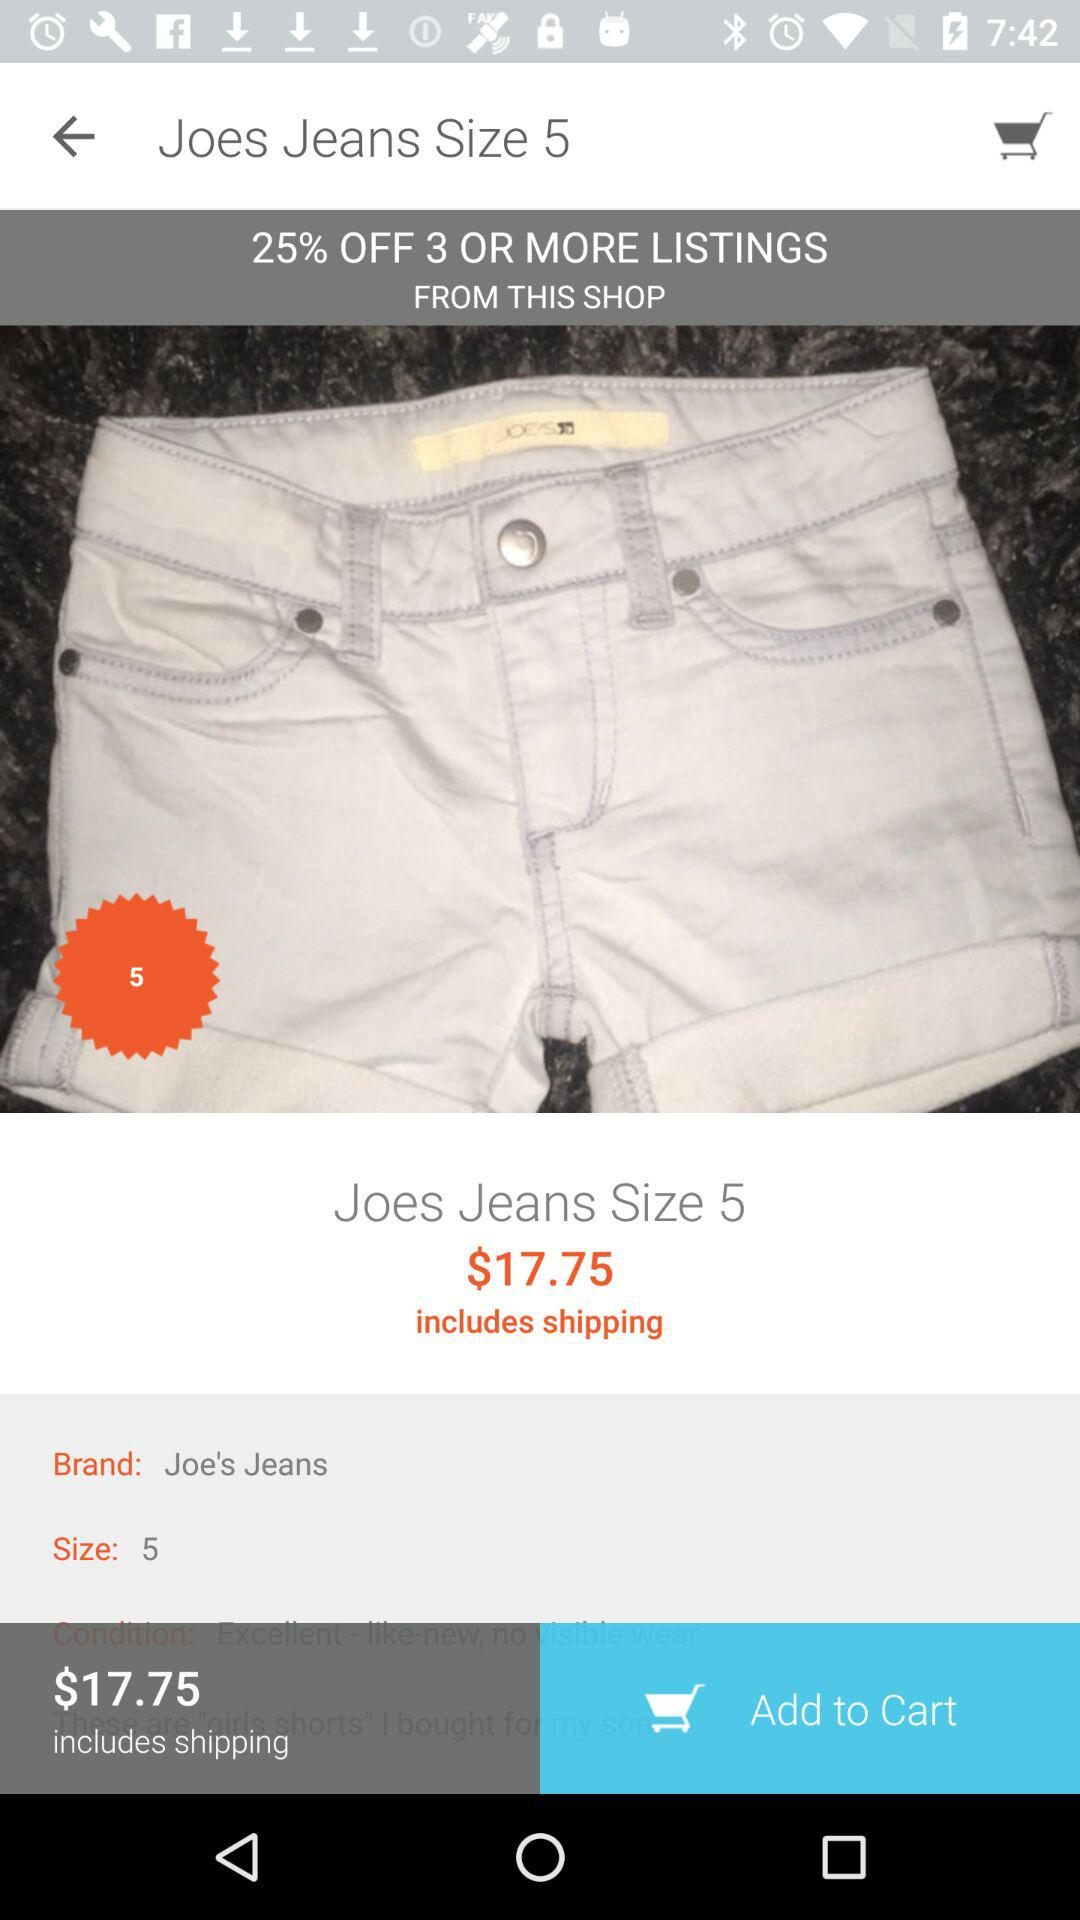What is the price of jeans? The cost of jeans is $17.75. 